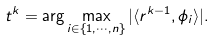<formula> <loc_0><loc_0><loc_500><loc_500>t ^ { k } = \arg \max _ { i \in \{ 1 , \cdots , n \} } | \langle r ^ { k - 1 } , \phi _ { i } \rangle | .</formula> 